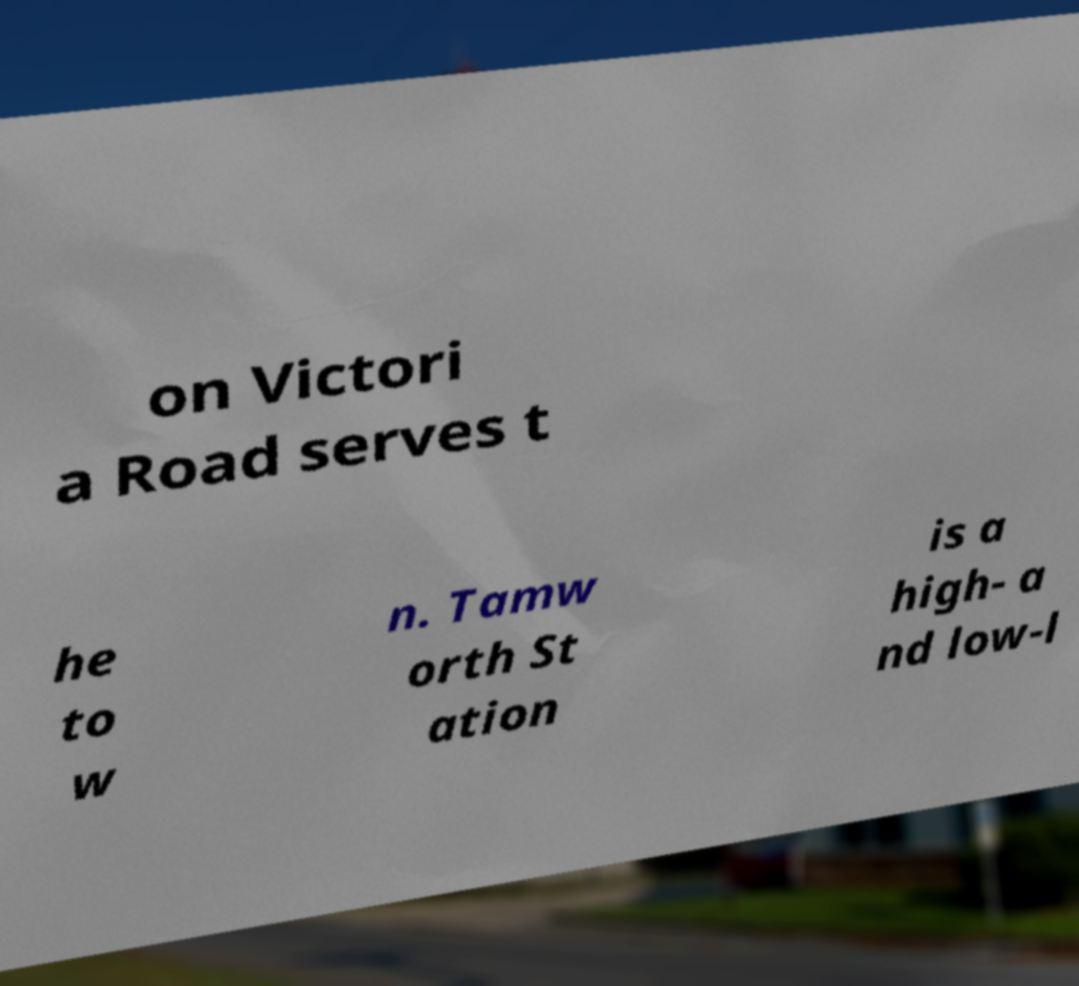Can you accurately transcribe the text from the provided image for me? on Victori a Road serves t he to w n. Tamw orth St ation is a high- a nd low-l 